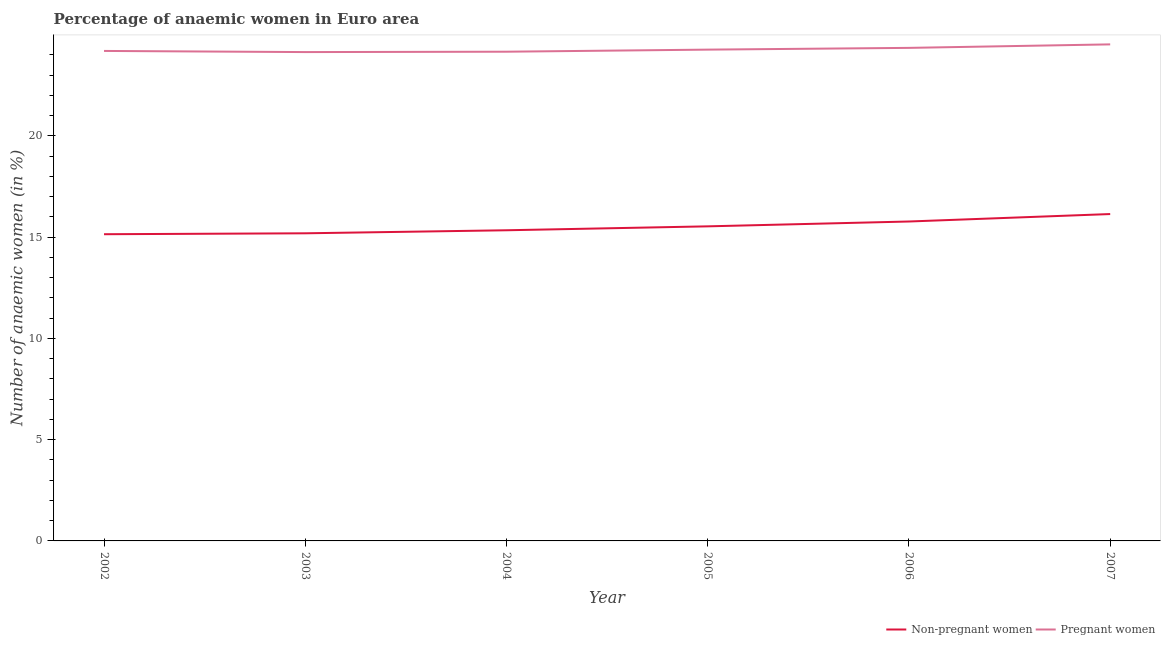How many different coloured lines are there?
Offer a very short reply. 2. Does the line corresponding to percentage of pregnant anaemic women intersect with the line corresponding to percentage of non-pregnant anaemic women?
Your response must be concise. No. Is the number of lines equal to the number of legend labels?
Offer a very short reply. Yes. What is the percentage of non-pregnant anaemic women in 2006?
Your answer should be very brief. 15.77. Across all years, what is the maximum percentage of non-pregnant anaemic women?
Offer a terse response. 16.14. Across all years, what is the minimum percentage of non-pregnant anaemic women?
Your response must be concise. 15.14. In which year was the percentage of non-pregnant anaemic women maximum?
Offer a very short reply. 2007. In which year was the percentage of non-pregnant anaemic women minimum?
Make the answer very short. 2002. What is the total percentage of non-pregnant anaemic women in the graph?
Keep it short and to the point. 93.1. What is the difference between the percentage of pregnant anaemic women in 2005 and that in 2006?
Give a very brief answer. -0.09. What is the difference between the percentage of pregnant anaemic women in 2002 and the percentage of non-pregnant anaemic women in 2006?
Your response must be concise. 8.42. What is the average percentage of pregnant anaemic women per year?
Ensure brevity in your answer.  24.26. In the year 2004, what is the difference between the percentage of non-pregnant anaemic women and percentage of pregnant anaemic women?
Your response must be concise. -8.82. In how many years, is the percentage of non-pregnant anaemic women greater than 9 %?
Give a very brief answer. 6. What is the ratio of the percentage of non-pregnant anaemic women in 2004 to that in 2006?
Make the answer very short. 0.97. Is the difference between the percentage of non-pregnant anaemic women in 2004 and 2005 greater than the difference between the percentage of pregnant anaemic women in 2004 and 2005?
Make the answer very short. No. What is the difference between the highest and the second highest percentage of pregnant anaemic women?
Keep it short and to the point. 0.17. What is the difference between the highest and the lowest percentage of non-pregnant anaemic women?
Provide a succinct answer. 1. Is the percentage of pregnant anaemic women strictly greater than the percentage of non-pregnant anaemic women over the years?
Give a very brief answer. Yes. How many lines are there?
Ensure brevity in your answer.  2. Are the values on the major ticks of Y-axis written in scientific E-notation?
Provide a short and direct response. No. Does the graph contain any zero values?
Offer a very short reply. No. Where does the legend appear in the graph?
Give a very brief answer. Bottom right. How many legend labels are there?
Provide a short and direct response. 2. What is the title of the graph?
Provide a short and direct response. Percentage of anaemic women in Euro area. What is the label or title of the X-axis?
Your answer should be very brief. Year. What is the label or title of the Y-axis?
Make the answer very short. Number of anaemic women (in %). What is the Number of anaemic women (in %) in Non-pregnant women in 2002?
Provide a short and direct response. 15.14. What is the Number of anaemic women (in %) of Pregnant women in 2002?
Offer a very short reply. 24.19. What is the Number of anaemic women (in %) of Non-pregnant women in 2003?
Make the answer very short. 15.19. What is the Number of anaemic women (in %) of Pregnant women in 2003?
Your response must be concise. 24.13. What is the Number of anaemic women (in %) in Non-pregnant women in 2004?
Offer a very short reply. 15.34. What is the Number of anaemic women (in %) in Pregnant women in 2004?
Ensure brevity in your answer.  24.15. What is the Number of anaemic women (in %) in Non-pregnant women in 2005?
Give a very brief answer. 15.53. What is the Number of anaemic women (in %) in Pregnant women in 2005?
Your answer should be compact. 24.26. What is the Number of anaemic women (in %) of Non-pregnant women in 2006?
Your answer should be very brief. 15.77. What is the Number of anaemic women (in %) of Pregnant women in 2006?
Keep it short and to the point. 24.34. What is the Number of anaemic women (in %) in Non-pregnant women in 2007?
Offer a very short reply. 16.14. What is the Number of anaemic women (in %) in Pregnant women in 2007?
Your answer should be compact. 24.51. Across all years, what is the maximum Number of anaemic women (in %) of Non-pregnant women?
Offer a very short reply. 16.14. Across all years, what is the maximum Number of anaemic women (in %) in Pregnant women?
Provide a short and direct response. 24.51. Across all years, what is the minimum Number of anaemic women (in %) of Non-pregnant women?
Your answer should be very brief. 15.14. Across all years, what is the minimum Number of anaemic women (in %) of Pregnant women?
Make the answer very short. 24.13. What is the total Number of anaemic women (in %) in Non-pregnant women in the graph?
Provide a short and direct response. 93.1. What is the total Number of anaemic women (in %) of Pregnant women in the graph?
Provide a short and direct response. 145.59. What is the difference between the Number of anaemic women (in %) of Non-pregnant women in 2002 and that in 2003?
Your answer should be very brief. -0.05. What is the difference between the Number of anaemic women (in %) of Pregnant women in 2002 and that in 2003?
Ensure brevity in your answer.  0.06. What is the difference between the Number of anaemic women (in %) in Non-pregnant women in 2002 and that in 2004?
Offer a very short reply. -0.2. What is the difference between the Number of anaemic women (in %) in Pregnant women in 2002 and that in 2004?
Your answer should be compact. 0.04. What is the difference between the Number of anaemic women (in %) of Non-pregnant women in 2002 and that in 2005?
Your answer should be compact. -0.39. What is the difference between the Number of anaemic women (in %) in Pregnant women in 2002 and that in 2005?
Give a very brief answer. -0.06. What is the difference between the Number of anaemic women (in %) of Non-pregnant women in 2002 and that in 2006?
Give a very brief answer. -0.63. What is the difference between the Number of anaemic women (in %) of Pregnant women in 2002 and that in 2006?
Ensure brevity in your answer.  -0.15. What is the difference between the Number of anaemic women (in %) of Non-pregnant women in 2002 and that in 2007?
Give a very brief answer. -1. What is the difference between the Number of anaemic women (in %) in Pregnant women in 2002 and that in 2007?
Provide a short and direct response. -0.32. What is the difference between the Number of anaemic women (in %) in Non-pregnant women in 2003 and that in 2004?
Make the answer very short. -0.15. What is the difference between the Number of anaemic women (in %) in Pregnant women in 2003 and that in 2004?
Offer a terse response. -0.02. What is the difference between the Number of anaemic women (in %) of Non-pregnant women in 2003 and that in 2005?
Provide a succinct answer. -0.34. What is the difference between the Number of anaemic women (in %) in Pregnant women in 2003 and that in 2005?
Your response must be concise. -0.12. What is the difference between the Number of anaemic women (in %) of Non-pregnant women in 2003 and that in 2006?
Offer a very short reply. -0.58. What is the difference between the Number of anaemic women (in %) of Pregnant women in 2003 and that in 2006?
Keep it short and to the point. -0.21. What is the difference between the Number of anaemic women (in %) of Non-pregnant women in 2003 and that in 2007?
Give a very brief answer. -0.95. What is the difference between the Number of anaemic women (in %) of Pregnant women in 2003 and that in 2007?
Provide a short and direct response. -0.38. What is the difference between the Number of anaemic women (in %) in Non-pregnant women in 2004 and that in 2005?
Give a very brief answer. -0.19. What is the difference between the Number of anaemic women (in %) of Pregnant women in 2004 and that in 2005?
Give a very brief answer. -0.1. What is the difference between the Number of anaemic women (in %) in Non-pregnant women in 2004 and that in 2006?
Your answer should be very brief. -0.43. What is the difference between the Number of anaemic women (in %) in Pregnant women in 2004 and that in 2006?
Your answer should be compact. -0.19. What is the difference between the Number of anaemic women (in %) in Non-pregnant women in 2004 and that in 2007?
Provide a short and direct response. -0.8. What is the difference between the Number of anaemic women (in %) in Pregnant women in 2004 and that in 2007?
Ensure brevity in your answer.  -0.36. What is the difference between the Number of anaemic women (in %) in Non-pregnant women in 2005 and that in 2006?
Your response must be concise. -0.24. What is the difference between the Number of anaemic women (in %) in Pregnant women in 2005 and that in 2006?
Offer a very short reply. -0.09. What is the difference between the Number of anaemic women (in %) of Non-pregnant women in 2005 and that in 2007?
Ensure brevity in your answer.  -0.61. What is the difference between the Number of anaemic women (in %) of Pregnant women in 2005 and that in 2007?
Provide a succinct answer. -0.26. What is the difference between the Number of anaemic women (in %) of Non-pregnant women in 2006 and that in 2007?
Provide a succinct answer. -0.37. What is the difference between the Number of anaemic women (in %) of Pregnant women in 2006 and that in 2007?
Offer a terse response. -0.17. What is the difference between the Number of anaemic women (in %) of Non-pregnant women in 2002 and the Number of anaemic women (in %) of Pregnant women in 2003?
Your answer should be compact. -8.99. What is the difference between the Number of anaemic women (in %) of Non-pregnant women in 2002 and the Number of anaemic women (in %) of Pregnant women in 2004?
Your response must be concise. -9.01. What is the difference between the Number of anaemic women (in %) of Non-pregnant women in 2002 and the Number of anaemic women (in %) of Pregnant women in 2005?
Provide a succinct answer. -9.11. What is the difference between the Number of anaemic women (in %) in Non-pregnant women in 2002 and the Number of anaemic women (in %) in Pregnant women in 2006?
Offer a terse response. -9.2. What is the difference between the Number of anaemic women (in %) in Non-pregnant women in 2002 and the Number of anaemic women (in %) in Pregnant women in 2007?
Your answer should be compact. -9.37. What is the difference between the Number of anaemic women (in %) in Non-pregnant women in 2003 and the Number of anaemic women (in %) in Pregnant women in 2004?
Provide a succinct answer. -8.97. What is the difference between the Number of anaemic women (in %) of Non-pregnant women in 2003 and the Number of anaemic women (in %) of Pregnant women in 2005?
Make the answer very short. -9.07. What is the difference between the Number of anaemic women (in %) of Non-pregnant women in 2003 and the Number of anaemic women (in %) of Pregnant women in 2006?
Offer a terse response. -9.15. What is the difference between the Number of anaemic women (in %) of Non-pregnant women in 2003 and the Number of anaemic women (in %) of Pregnant women in 2007?
Provide a succinct answer. -9.33. What is the difference between the Number of anaemic women (in %) in Non-pregnant women in 2004 and the Number of anaemic women (in %) in Pregnant women in 2005?
Offer a terse response. -8.92. What is the difference between the Number of anaemic women (in %) in Non-pregnant women in 2004 and the Number of anaemic women (in %) in Pregnant women in 2006?
Keep it short and to the point. -9. What is the difference between the Number of anaemic women (in %) of Non-pregnant women in 2004 and the Number of anaemic women (in %) of Pregnant women in 2007?
Offer a terse response. -9.18. What is the difference between the Number of anaemic women (in %) of Non-pregnant women in 2005 and the Number of anaemic women (in %) of Pregnant women in 2006?
Give a very brief answer. -8.81. What is the difference between the Number of anaemic women (in %) in Non-pregnant women in 2005 and the Number of anaemic women (in %) in Pregnant women in 2007?
Give a very brief answer. -8.98. What is the difference between the Number of anaemic women (in %) in Non-pregnant women in 2006 and the Number of anaemic women (in %) in Pregnant women in 2007?
Give a very brief answer. -8.74. What is the average Number of anaemic women (in %) of Non-pregnant women per year?
Your answer should be very brief. 15.52. What is the average Number of anaemic women (in %) of Pregnant women per year?
Offer a very short reply. 24.26. In the year 2002, what is the difference between the Number of anaemic women (in %) in Non-pregnant women and Number of anaemic women (in %) in Pregnant women?
Your response must be concise. -9.05. In the year 2003, what is the difference between the Number of anaemic women (in %) in Non-pregnant women and Number of anaemic women (in %) in Pregnant women?
Provide a succinct answer. -8.95. In the year 2004, what is the difference between the Number of anaemic women (in %) of Non-pregnant women and Number of anaemic women (in %) of Pregnant women?
Offer a terse response. -8.82. In the year 2005, what is the difference between the Number of anaemic women (in %) of Non-pregnant women and Number of anaemic women (in %) of Pregnant women?
Offer a terse response. -8.72. In the year 2006, what is the difference between the Number of anaemic women (in %) of Non-pregnant women and Number of anaemic women (in %) of Pregnant women?
Make the answer very short. -8.57. In the year 2007, what is the difference between the Number of anaemic women (in %) in Non-pregnant women and Number of anaemic women (in %) in Pregnant women?
Offer a terse response. -8.38. What is the ratio of the Number of anaemic women (in %) of Non-pregnant women in 2002 to that in 2003?
Keep it short and to the point. 1. What is the ratio of the Number of anaemic women (in %) of Non-pregnant women in 2002 to that in 2004?
Ensure brevity in your answer.  0.99. What is the ratio of the Number of anaemic women (in %) in Non-pregnant women in 2002 to that in 2005?
Keep it short and to the point. 0.97. What is the ratio of the Number of anaemic women (in %) in Pregnant women in 2002 to that in 2005?
Your answer should be very brief. 1. What is the ratio of the Number of anaemic women (in %) in Non-pregnant women in 2002 to that in 2006?
Ensure brevity in your answer.  0.96. What is the ratio of the Number of anaemic women (in %) in Pregnant women in 2002 to that in 2006?
Your response must be concise. 0.99. What is the ratio of the Number of anaemic women (in %) in Non-pregnant women in 2002 to that in 2007?
Offer a very short reply. 0.94. What is the ratio of the Number of anaemic women (in %) in Non-pregnant women in 2003 to that in 2004?
Give a very brief answer. 0.99. What is the ratio of the Number of anaemic women (in %) of Pregnant women in 2003 to that in 2004?
Offer a very short reply. 1. What is the ratio of the Number of anaemic women (in %) of Non-pregnant women in 2003 to that in 2005?
Give a very brief answer. 0.98. What is the ratio of the Number of anaemic women (in %) of Pregnant women in 2003 to that in 2005?
Give a very brief answer. 0.99. What is the ratio of the Number of anaemic women (in %) of Non-pregnant women in 2003 to that in 2006?
Make the answer very short. 0.96. What is the ratio of the Number of anaemic women (in %) in Non-pregnant women in 2003 to that in 2007?
Offer a terse response. 0.94. What is the ratio of the Number of anaemic women (in %) in Pregnant women in 2003 to that in 2007?
Provide a succinct answer. 0.98. What is the ratio of the Number of anaemic women (in %) of Non-pregnant women in 2004 to that in 2005?
Offer a very short reply. 0.99. What is the ratio of the Number of anaemic women (in %) in Pregnant women in 2004 to that in 2005?
Give a very brief answer. 1. What is the ratio of the Number of anaemic women (in %) of Non-pregnant women in 2004 to that in 2006?
Your answer should be compact. 0.97. What is the ratio of the Number of anaemic women (in %) of Non-pregnant women in 2004 to that in 2007?
Your response must be concise. 0.95. What is the ratio of the Number of anaemic women (in %) of Pregnant women in 2004 to that in 2007?
Provide a succinct answer. 0.99. What is the ratio of the Number of anaemic women (in %) of Non-pregnant women in 2005 to that in 2007?
Give a very brief answer. 0.96. What is the ratio of the Number of anaemic women (in %) of Pregnant women in 2005 to that in 2007?
Provide a short and direct response. 0.99. What is the ratio of the Number of anaemic women (in %) of Non-pregnant women in 2006 to that in 2007?
Offer a very short reply. 0.98. What is the ratio of the Number of anaemic women (in %) in Pregnant women in 2006 to that in 2007?
Your answer should be compact. 0.99. What is the difference between the highest and the second highest Number of anaemic women (in %) in Non-pregnant women?
Give a very brief answer. 0.37. What is the difference between the highest and the second highest Number of anaemic women (in %) in Pregnant women?
Make the answer very short. 0.17. What is the difference between the highest and the lowest Number of anaemic women (in %) in Pregnant women?
Offer a very short reply. 0.38. 